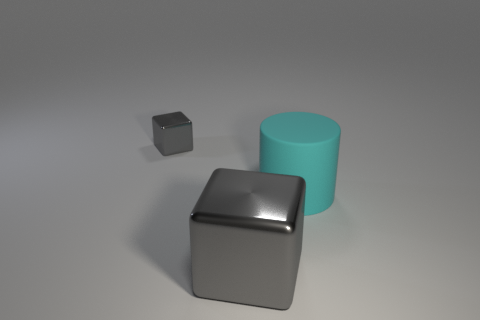Is there a large metal object that has the same color as the small cube?
Offer a terse response. Yes. How many big things are either red matte objects or gray blocks?
Your answer should be very brief. 1. What is the color of the other block that is the same material as the big block?
Give a very brief answer. Gray. How many large gray things have the same material as the small gray block?
Your answer should be very brief. 1. There is a gray object in front of the large rubber cylinder; is it the same size as the object that is right of the big gray cube?
Provide a short and direct response. Yes. There is a object that is to the right of the cube that is on the right side of the small metal cube; what is it made of?
Your response must be concise. Rubber. Is the number of small gray cubes in front of the small object less than the number of tiny gray things behind the cyan cylinder?
Your answer should be very brief. Yes. Are there any other things that have the same shape as the cyan rubber thing?
Your response must be concise. No. There is a gray cube that is behind the big matte thing; what material is it?
Provide a succinct answer. Metal. There is a big metal block; are there any blocks behind it?
Provide a succinct answer. Yes. 